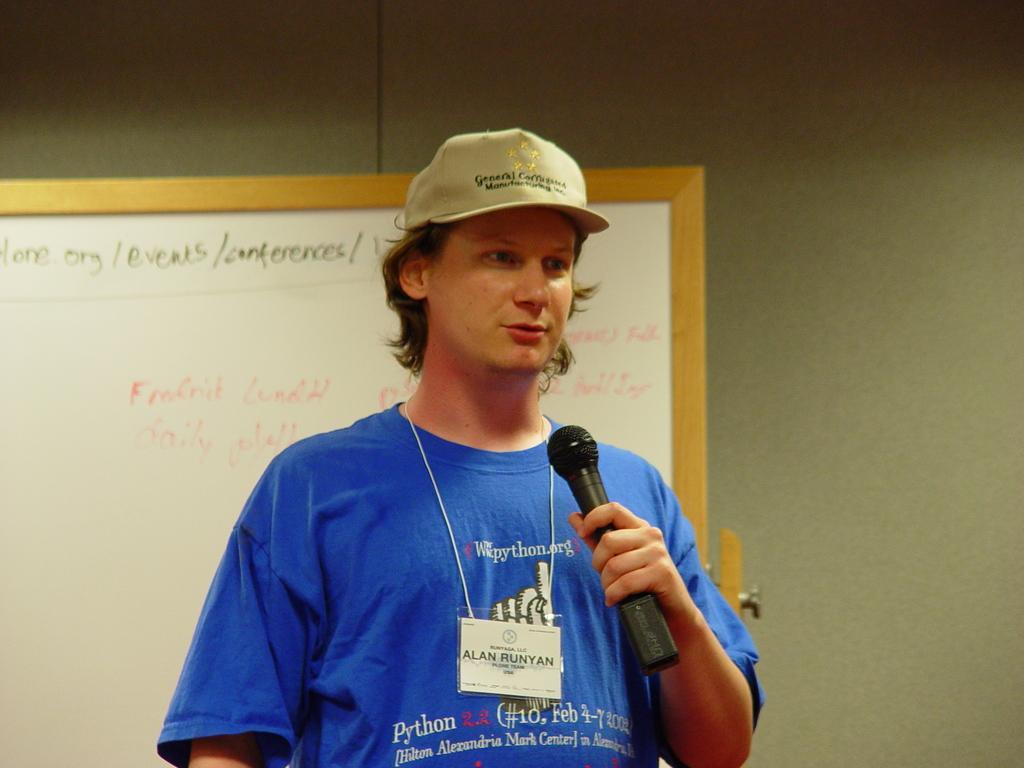Can you describe this image briefly? There is a man standing wearing a cap holding microphone behind him there is a board. 